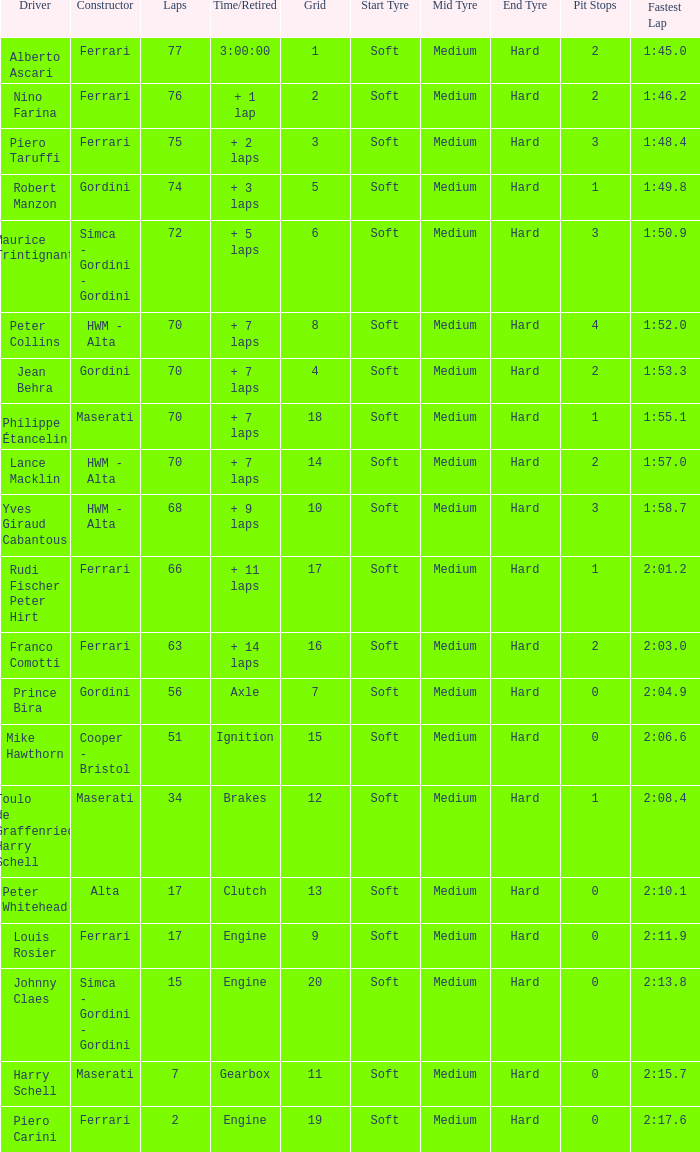Who drove the car with over 66 laps with a grid of 5? Robert Manzon. 